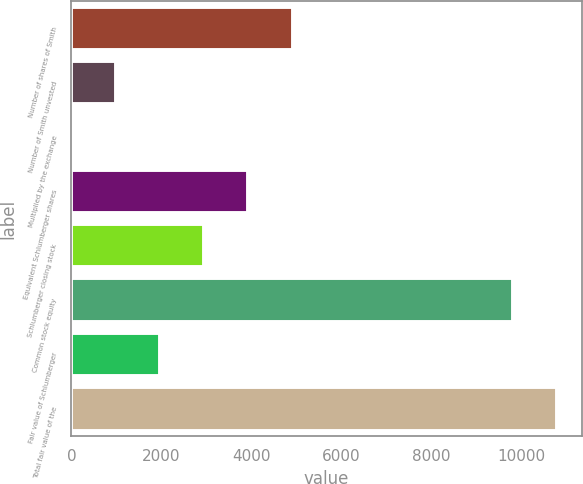Convert chart. <chart><loc_0><loc_0><loc_500><loc_500><bar_chart><fcel>Number of shares of Smith<fcel>Number of Smith unvested<fcel>Multiplied by the exchange<fcel>Equivalent Schlumberger shares<fcel>Schlumberger closing stock<fcel>Common stock equity<fcel>Fair value of Schlumberger<fcel>Total fair value of the<nl><fcel>4914.35<fcel>983.43<fcel>0.7<fcel>3931.62<fcel>2948.89<fcel>9812<fcel>1966.16<fcel>10794.7<nl></chart> 